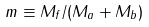Convert formula to latex. <formula><loc_0><loc_0><loc_500><loc_500>m \equiv M _ { f } / ( M _ { a } + M _ { b } )</formula> 